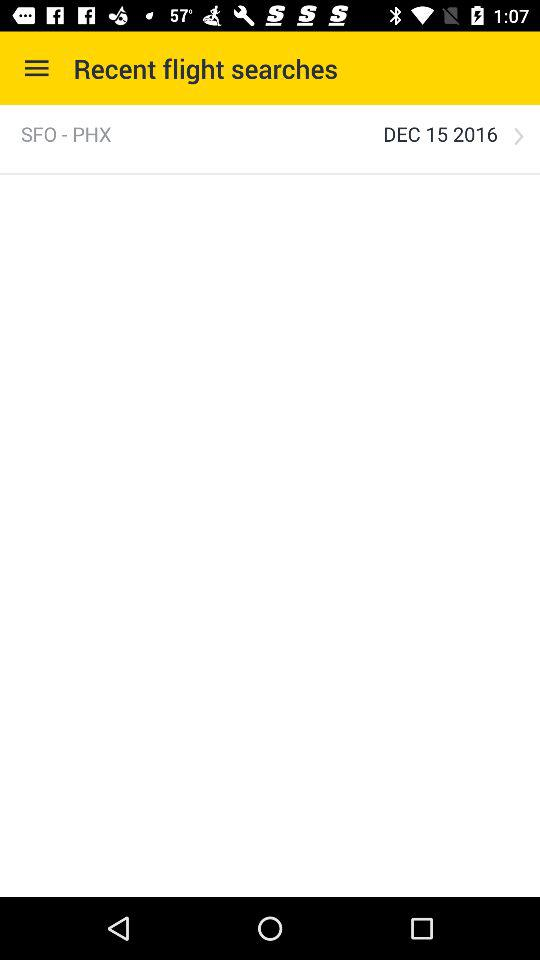What is the given date? The given date is December 15, 2016. 